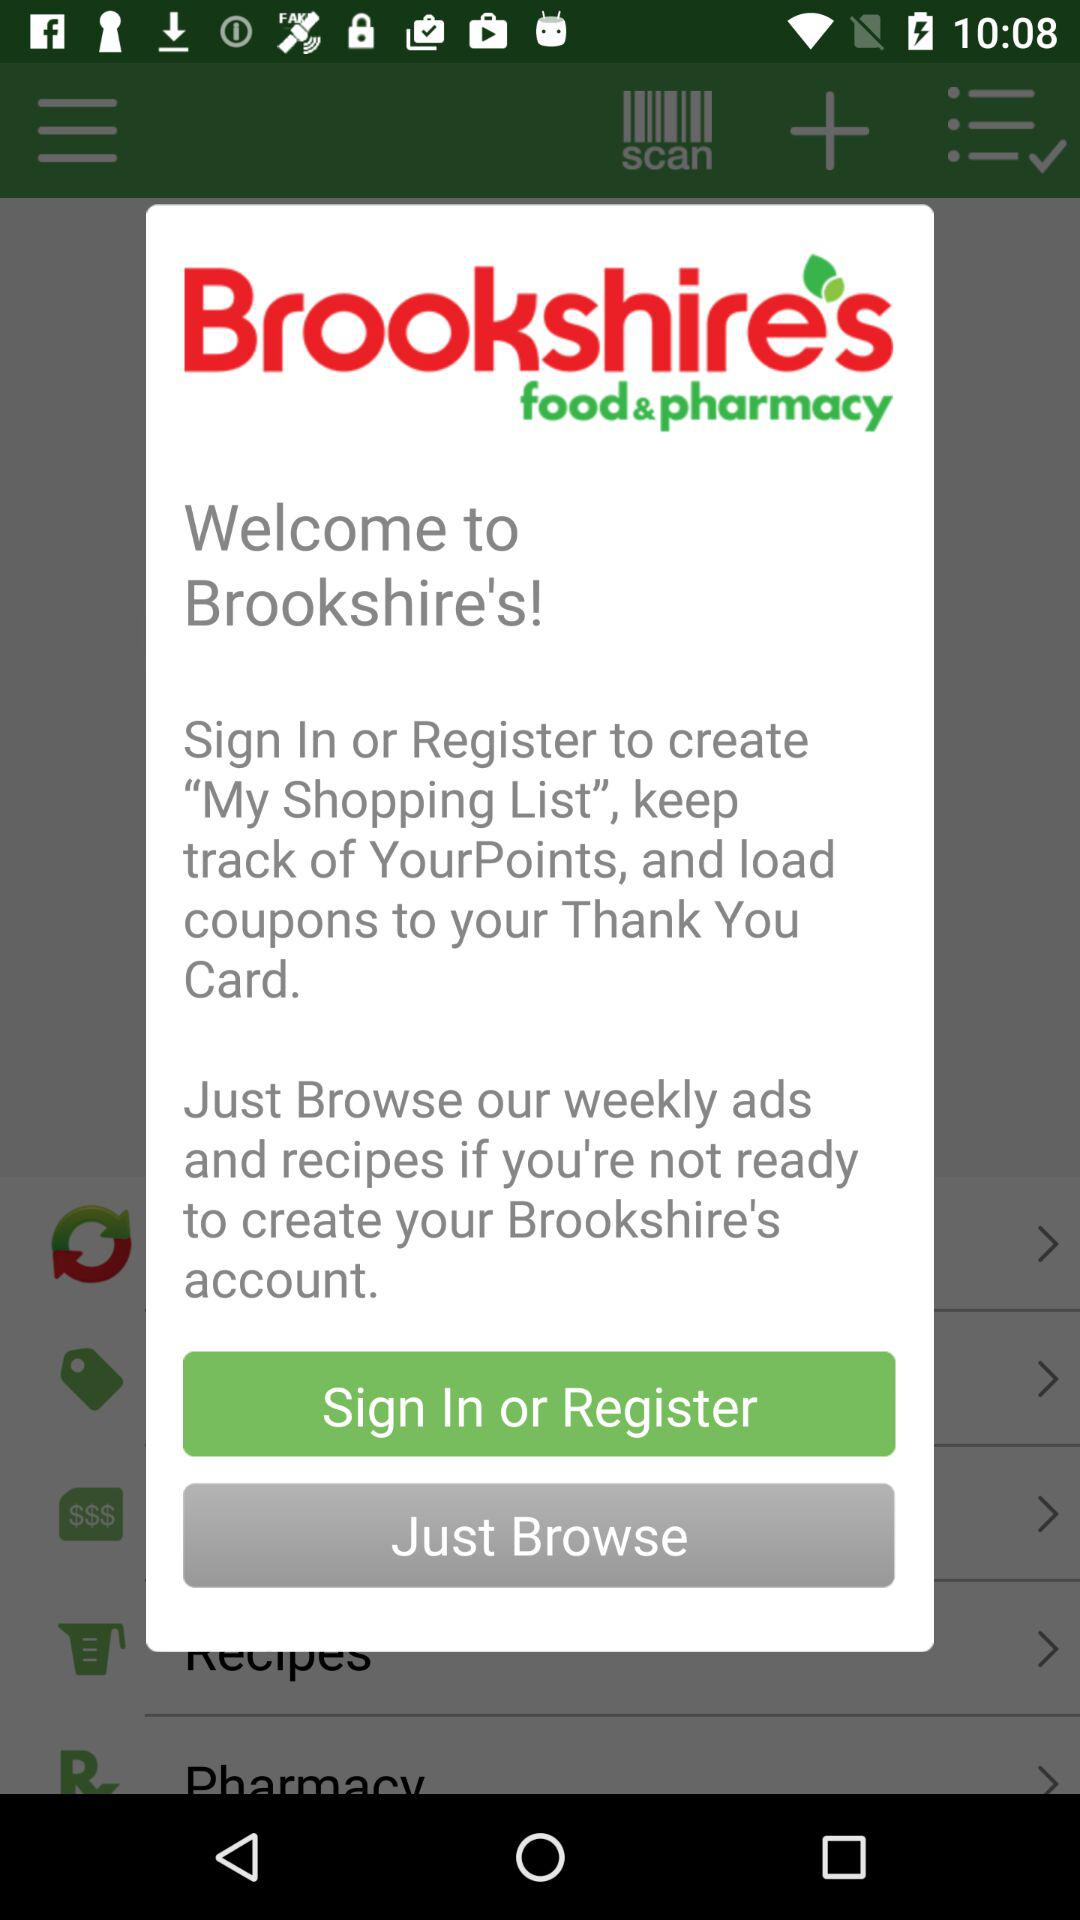What is the name of the application? The name of the application is "Brookshire's". 